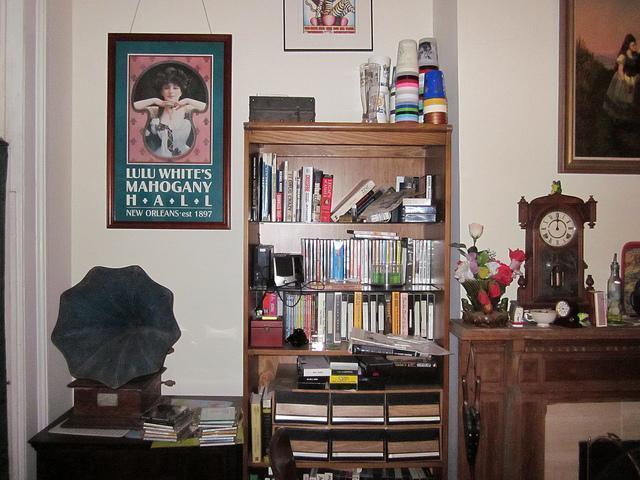Where is this bookshelf located?
Make your selection from the four choices given to correctly answer the question.
Options: Home, courtroom, store, library. Home. 